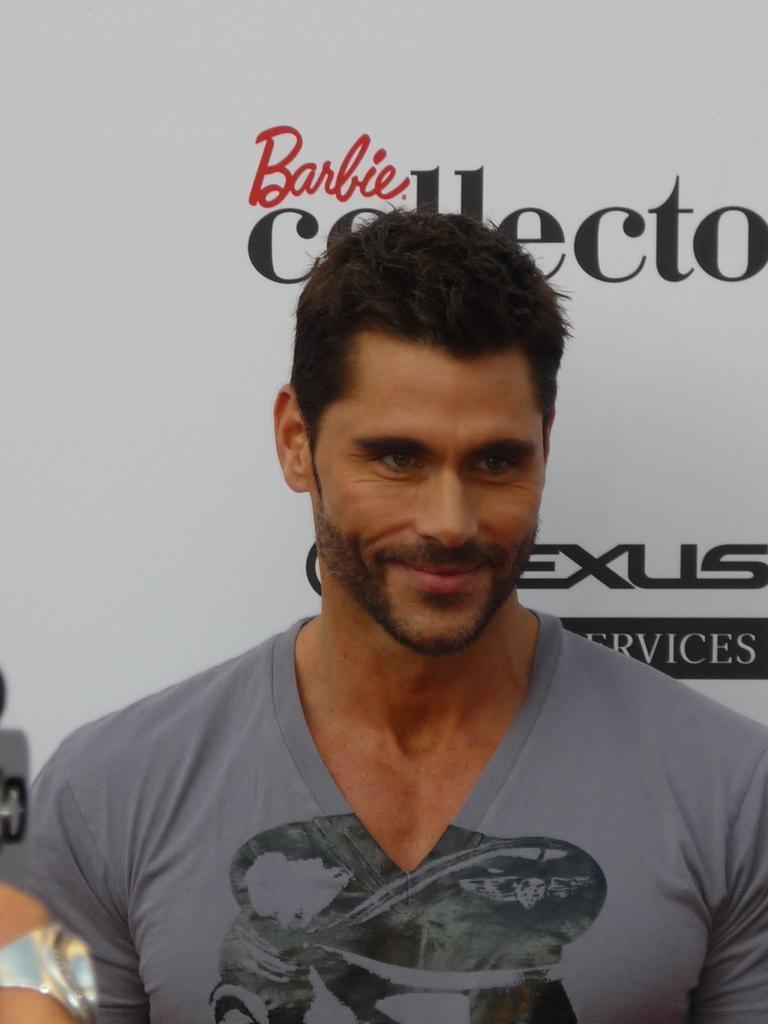Please provide a concise description of this image. In the picture we can see a man standing with a gray color T-shirt and he is smiling and behind him we can see a white color banner with some advertisement on it. 